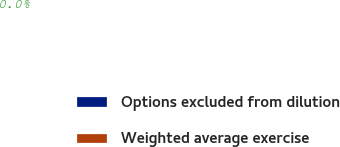Convert chart. <chart><loc_0><loc_0><loc_500><loc_500><pie_chart><fcel>Options excluded from dilution<fcel>Weighted average exercise<nl><fcel>100.0%<fcel>0.0%<nl></chart> 